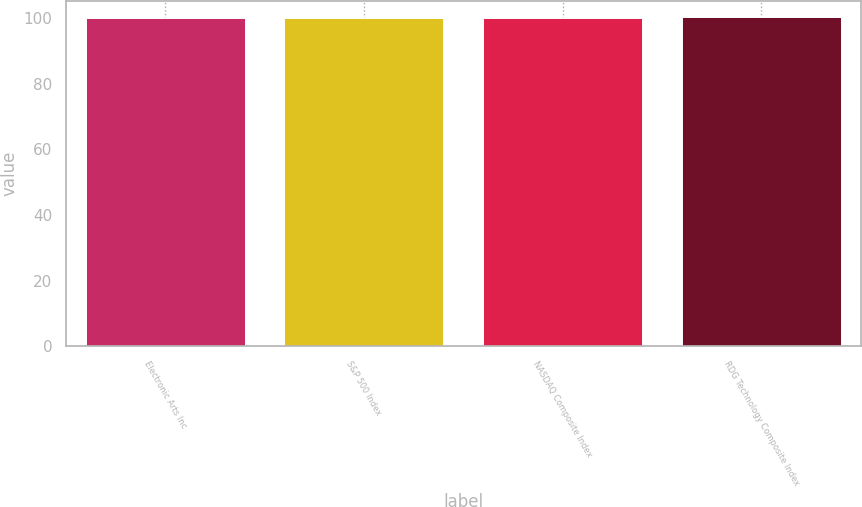<chart> <loc_0><loc_0><loc_500><loc_500><bar_chart><fcel>Electronic Arts Inc<fcel>S&P 500 Index<fcel>NASDAQ Composite Index<fcel>RDG Technology Composite Index<nl><fcel>100<fcel>100.1<fcel>100.2<fcel>100.3<nl></chart> 